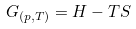Convert formula to latex. <formula><loc_0><loc_0><loc_500><loc_500>G _ { ( p , T ) } = H - T S</formula> 